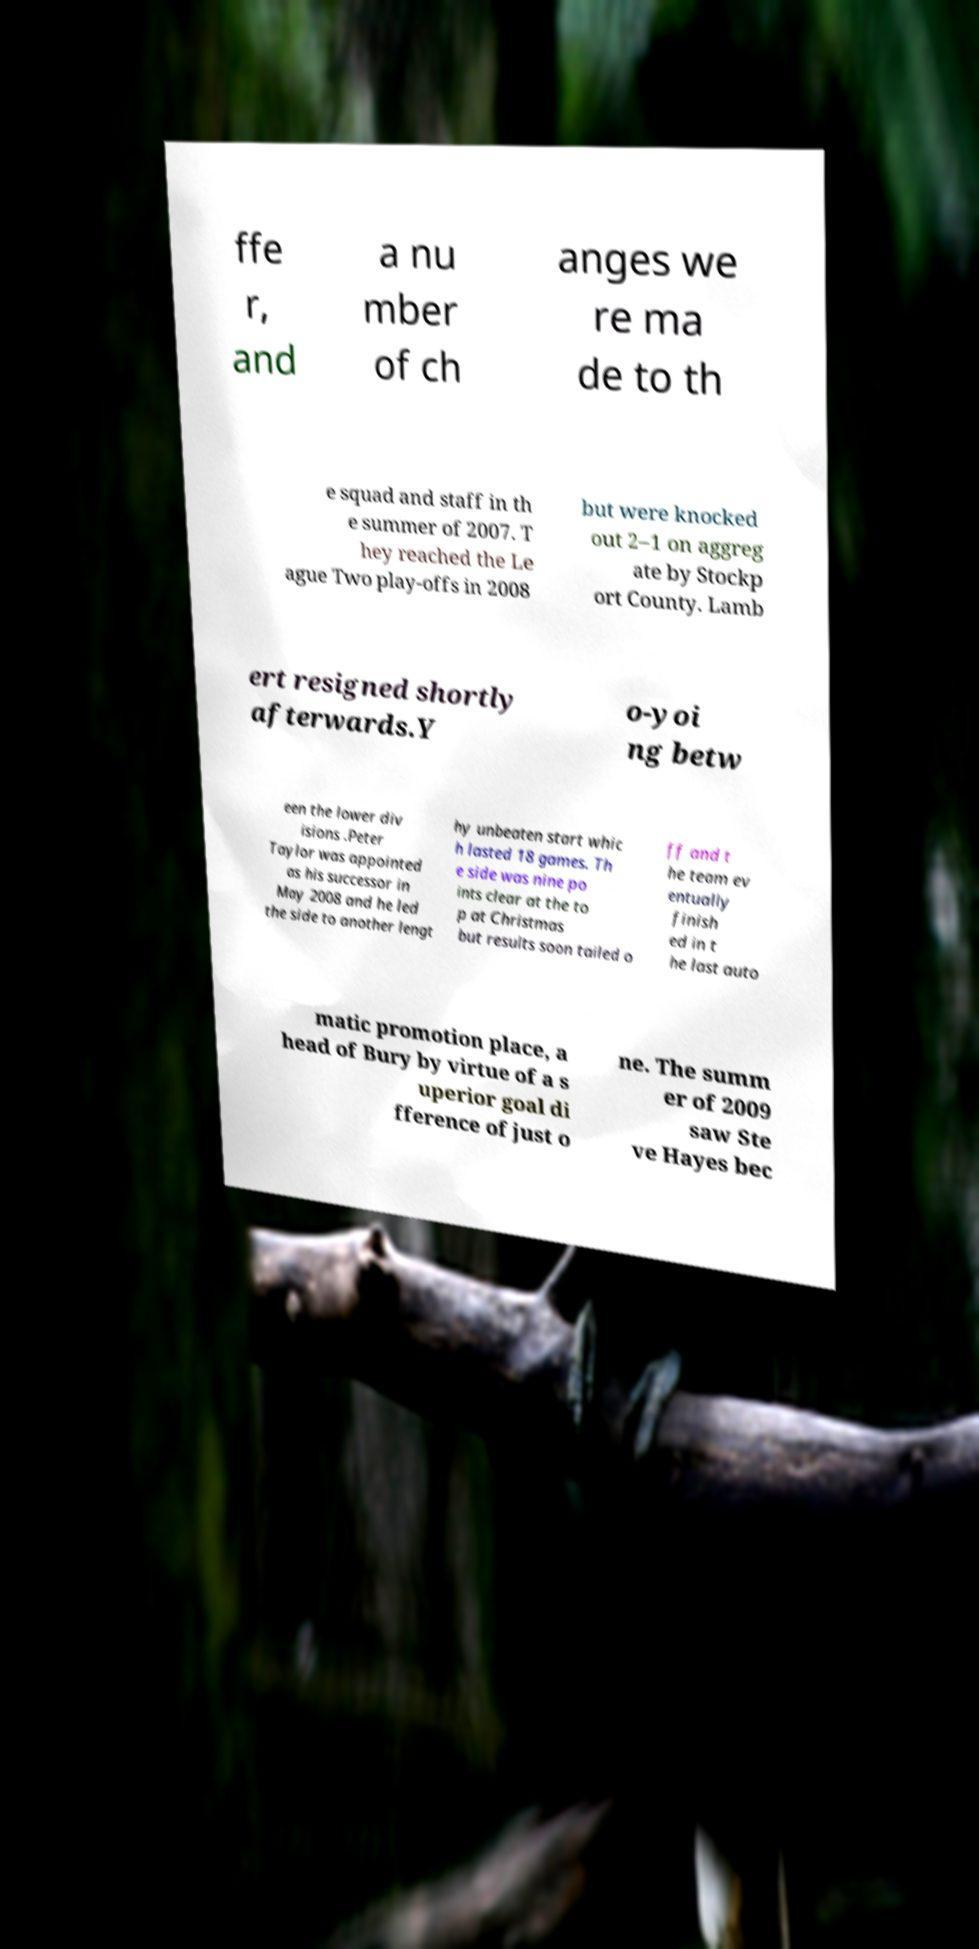I need the written content from this picture converted into text. Can you do that? ffe r, and a nu mber of ch anges we re ma de to th e squad and staff in th e summer of 2007. T hey reached the Le ague Two play-offs in 2008 but were knocked out 2–1 on aggreg ate by Stockp ort County. Lamb ert resigned shortly afterwards.Y o-yoi ng betw een the lower div isions .Peter Taylor was appointed as his successor in May 2008 and he led the side to another lengt hy unbeaten start whic h lasted 18 games. Th e side was nine po ints clear at the to p at Christmas but results soon tailed o ff and t he team ev entually finish ed in t he last auto matic promotion place, a head of Bury by virtue of a s uperior goal di fference of just o ne. The summ er of 2009 saw Ste ve Hayes bec 